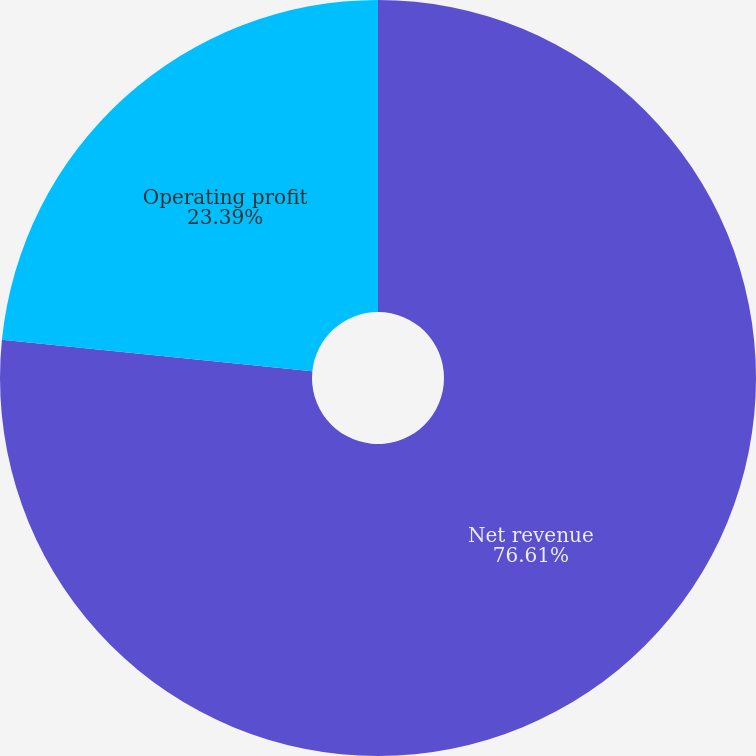<chart> <loc_0><loc_0><loc_500><loc_500><pie_chart><fcel>Net revenue<fcel>Operating profit<nl><fcel>76.61%<fcel>23.39%<nl></chart> 